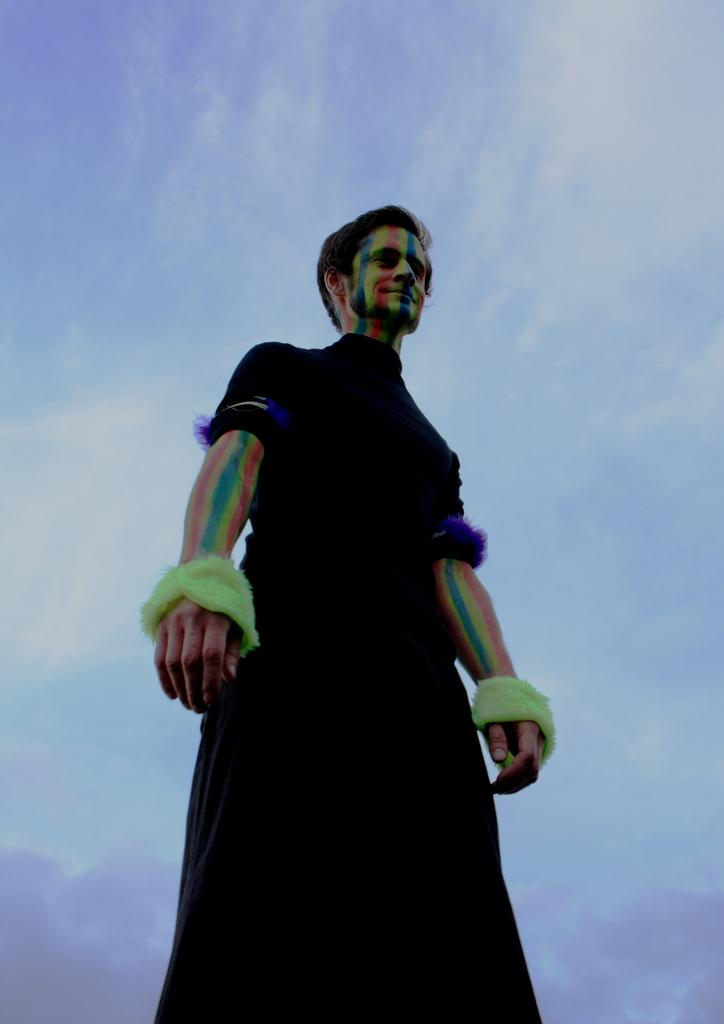Who is present in the image? There is a man in the image. What is the man wearing? The man is wearing a black dress. What can be seen in the background of the image? The sky is visible in the background of the image. What is the condition of the sky in the image? The sky is cloudy in the image. How many frogs can be seen swimming in the river in the image? There is no river or frogs present in the image. 